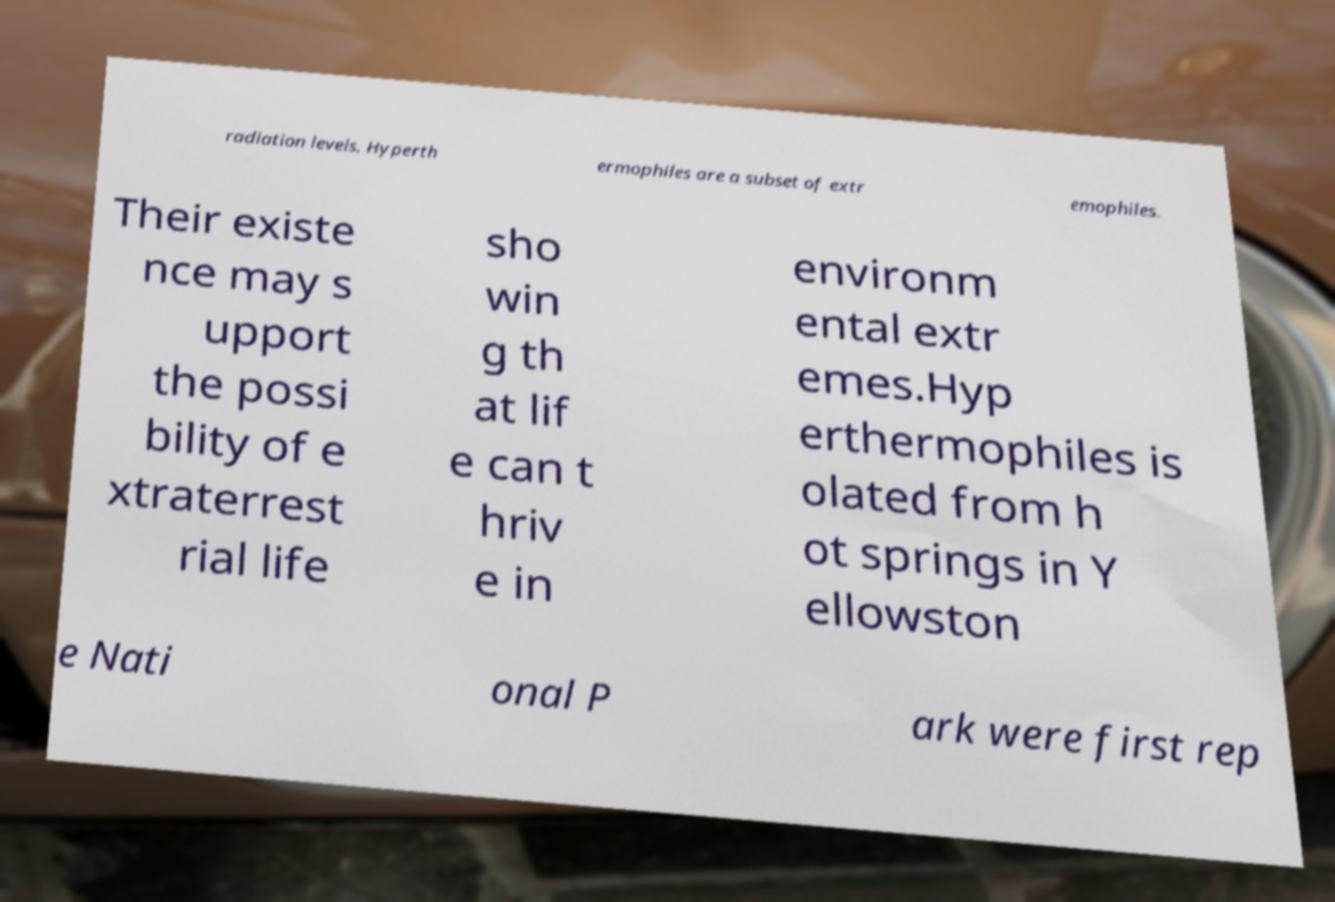For documentation purposes, I need the text within this image transcribed. Could you provide that? radiation levels. Hyperth ermophiles are a subset of extr emophiles. Their existe nce may s upport the possi bility of e xtraterrest rial life sho win g th at lif e can t hriv e in environm ental extr emes.Hyp erthermophiles is olated from h ot springs in Y ellowston e Nati onal P ark were first rep 